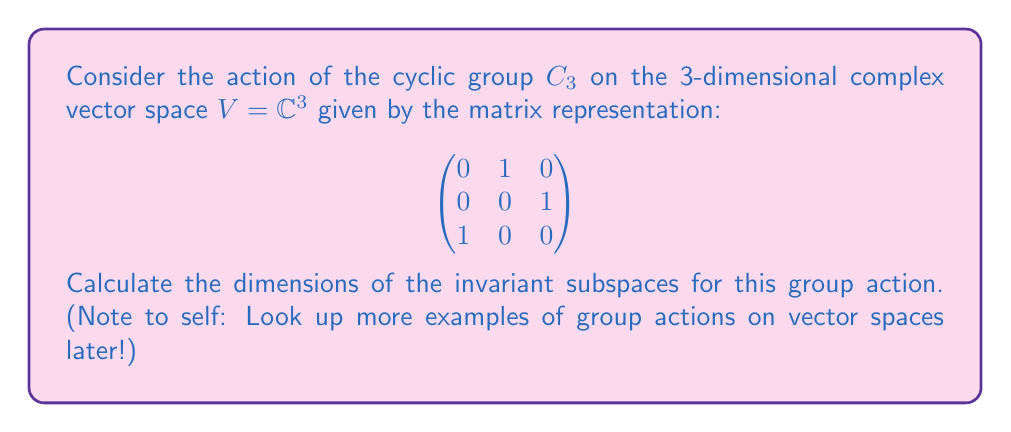Solve this math problem. 1) First, we need to find the eigenvalues of the matrix $A$. The characteristic polynomial is:

   $$\det(A - \lambda I) = -\lambda^3 + 1 = -(\lambda^3 - 1) = -(\lambda - 1)(\lambda - \omega)(\lambda - \omega^2)$$

   where $\omega = e^{2\pi i/3}$ is a primitive cubic root of unity.

2) The eigenvalues are therefore $1, \omega, \omega^2$.

3) For each eigenvalue $\lambda$, the corresponding eigenspace $E_\lambda$ is an invariant subspace.

4) To find the dimension of each eigenspace, we solve $(A - \lambda I)v = 0$ for each $\lambda$:

   For $\lambda = 1$:
   $$\begin{pmatrix}
   -1 & 1 & 0 \\
   0 & -1 & 1 \\
   1 & 0 & -1
   \end{pmatrix}\begin{pmatrix} v_1 \\ v_2 \\ v_3 \end{pmatrix} = \begin{pmatrix} 0 \\ 0 \\ 0 \end{pmatrix}$$
   This gives $v_1 = v_2 = v_3$, so $\dim E_1 = 1$.

   For $\lambda = \omega$ and $\lambda = \omega^2$, similar calculations show that $\dim E_\omega = \dim E_{\omega^2} = 1$.

5) The invariant subspaces are precisely these eigenspaces, and their dimensions are all 1.

6) Note that $\dim V = 3 = 1 + 1 + 1$, which confirms that we've found all invariant subspaces.
Answer: $\dim E_1 = 1$, $\dim E_\omega = 1$, $\dim E_{\omega^2} = 1$ 